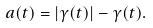Convert formula to latex. <formula><loc_0><loc_0><loc_500><loc_500>a ( t ) = | \gamma ( t ) | - \gamma ( t ) .</formula> 